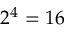Convert formula to latex. <formula><loc_0><loc_0><loc_500><loc_500>2 ^ { 4 } = 1 6</formula> 